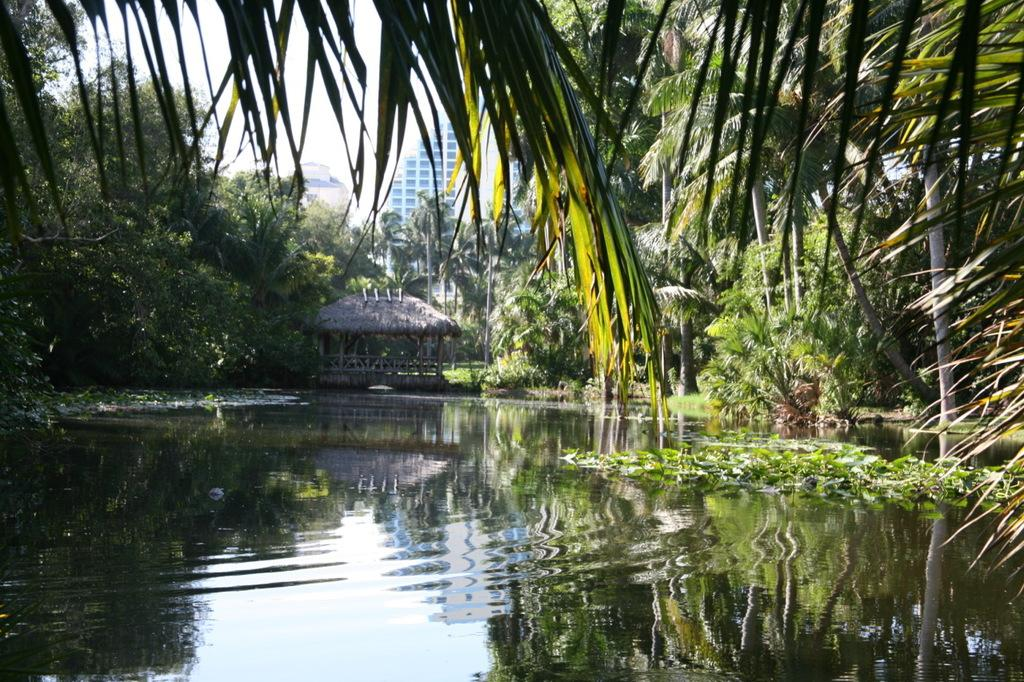What can be seen in the sky in the image? The sky is visible in the image, and clouds are present. What type of structures can be seen in the image? There are buildings in the image. What type of vegetation is present in the image? Trees and grass are present in the image. What type of barrier can be seen in the image? Fences are visible in the image. What type of water feature is present in the image? There is water visible in the image. What type of small shelter is present in the image? There is a shed in the image. What other objects can be seen in the image? There are a few other objects in the image. How many buttons are visible on the trees in the image? There are no buttons present on the trees in the image. What type of place is depicted in the image? The image does not depict a specific place; it shows a combination of natural and man-made elements. 